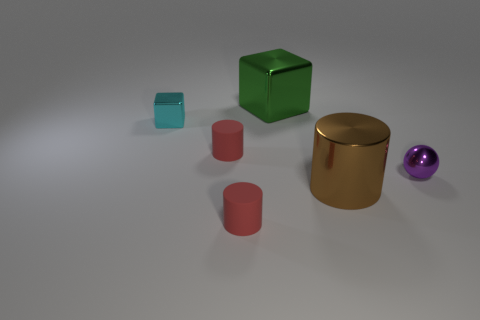Subtract all tiny red rubber cylinders. How many cylinders are left? 1 Add 2 big green shiny objects. How many objects exist? 8 Subtract all brown cylinders. How many cylinders are left? 2 Subtract all blocks. How many objects are left? 4 Subtract 2 cubes. How many cubes are left? 0 Subtract all small blue objects. Subtract all brown shiny objects. How many objects are left? 5 Add 5 tiny purple shiny objects. How many tiny purple shiny objects are left? 6 Add 2 big purple cylinders. How many big purple cylinders exist? 2 Subtract 0 red blocks. How many objects are left? 6 Subtract all cyan blocks. Subtract all purple balls. How many blocks are left? 1 